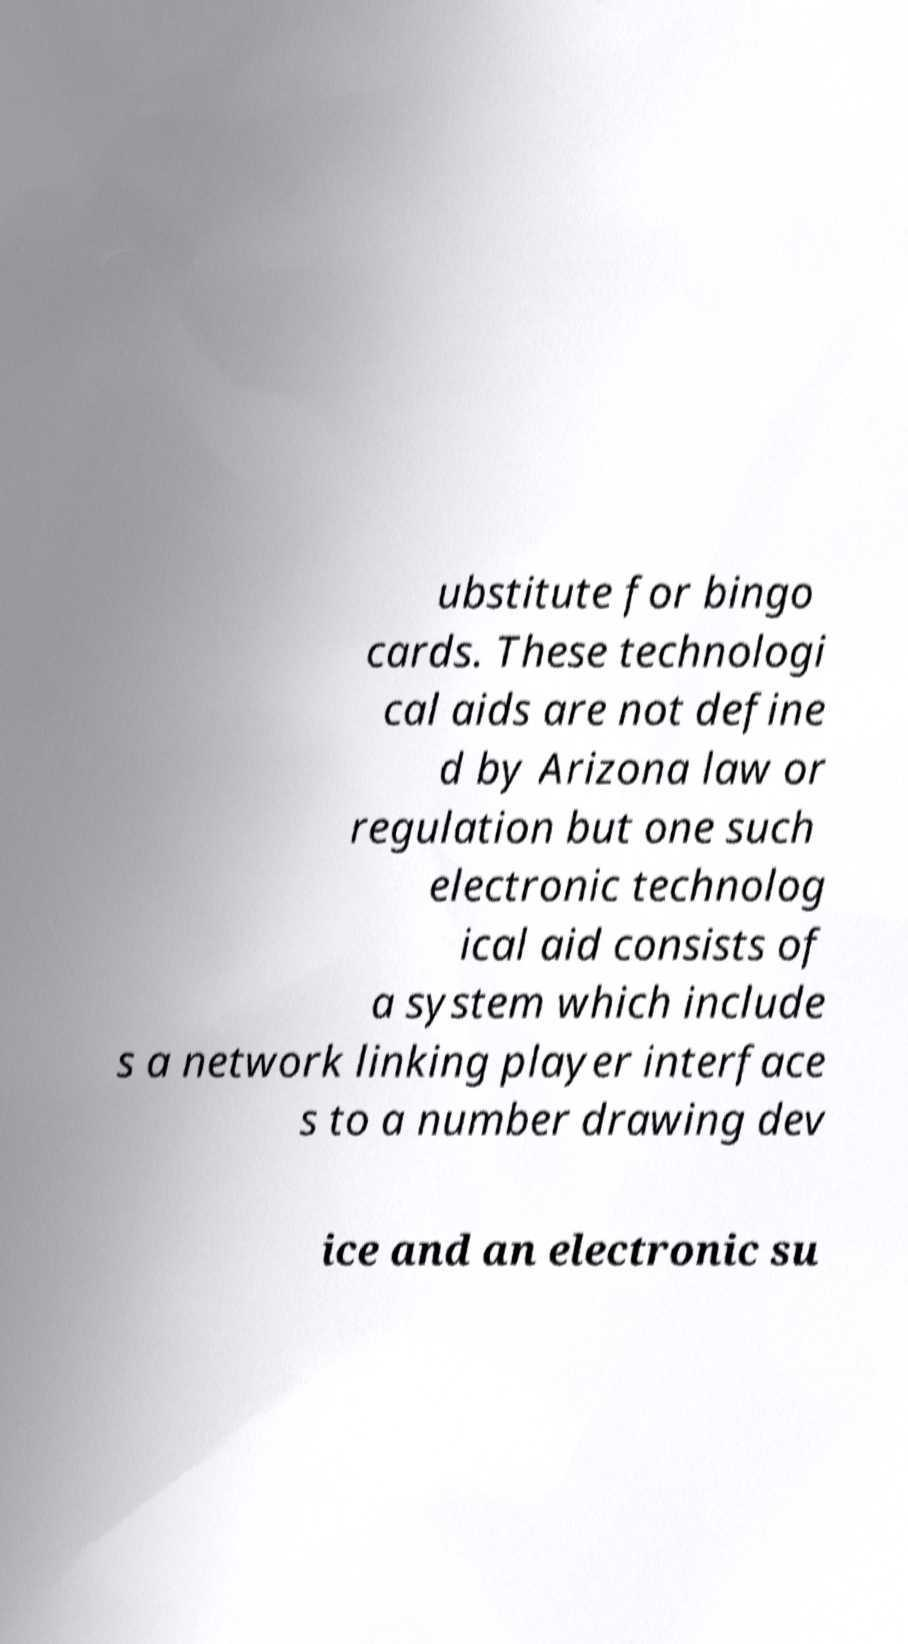Could you assist in decoding the text presented in this image and type it out clearly? ubstitute for bingo cards. These technologi cal aids are not define d by Arizona law or regulation but one such electronic technolog ical aid consists of a system which include s a network linking player interface s to a number drawing dev ice and an electronic su 